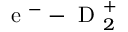Convert formula to latex. <formula><loc_0><loc_0><loc_500><loc_500>e ^ { - } - D _ { 2 } ^ { + }</formula> 